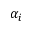Convert formula to latex. <formula><loc_0><loc_0><loc_500><loc_500>\alpha _ { i }</formula> 